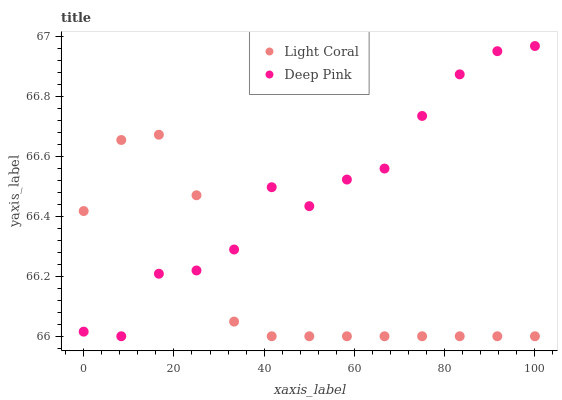Does Light Coral have the minimum area under the curve?
Answer yes or no. Yes. Does Deep Pink have the maximum area under the curve?
Answer yes or no. Yes. Does Deep Pink have the minimum area under the curve?
Answer yes or no. No. Is Light Coral the smoothest?
Answer yes or no. Yes. Is Deep Pink the roughest?
Answer yes or no. Yes. Is Deep Pink the smoothest?
Answer yes or no. No. Does Light Coral have the lowest value?
Answer yes or no. Yes. Does Deep Pink have the highest value?
Answer yes or no. Yes. Does Deep Pink intersect Light Coral?
Answer yes or no. Yes. Is Deep Pink less than Light Coral?
Answer yes or no. No. Is Deep Pink greater than Light Coral?
Answer yes or no. No. 